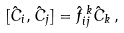<formula> <loc_0><loc_0><loc_500><loc_500>[ \hat { C } _ { i } , \hat { C } _ { j } ] = \hat { f } _ { i j } ^ { \, k } \hat { C } _ { k } \, ,</formula> 